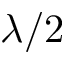Convert formula to latex. <formula><loc_0><loc_0><loc_500><loc_500>\lambda / 2</formula> 